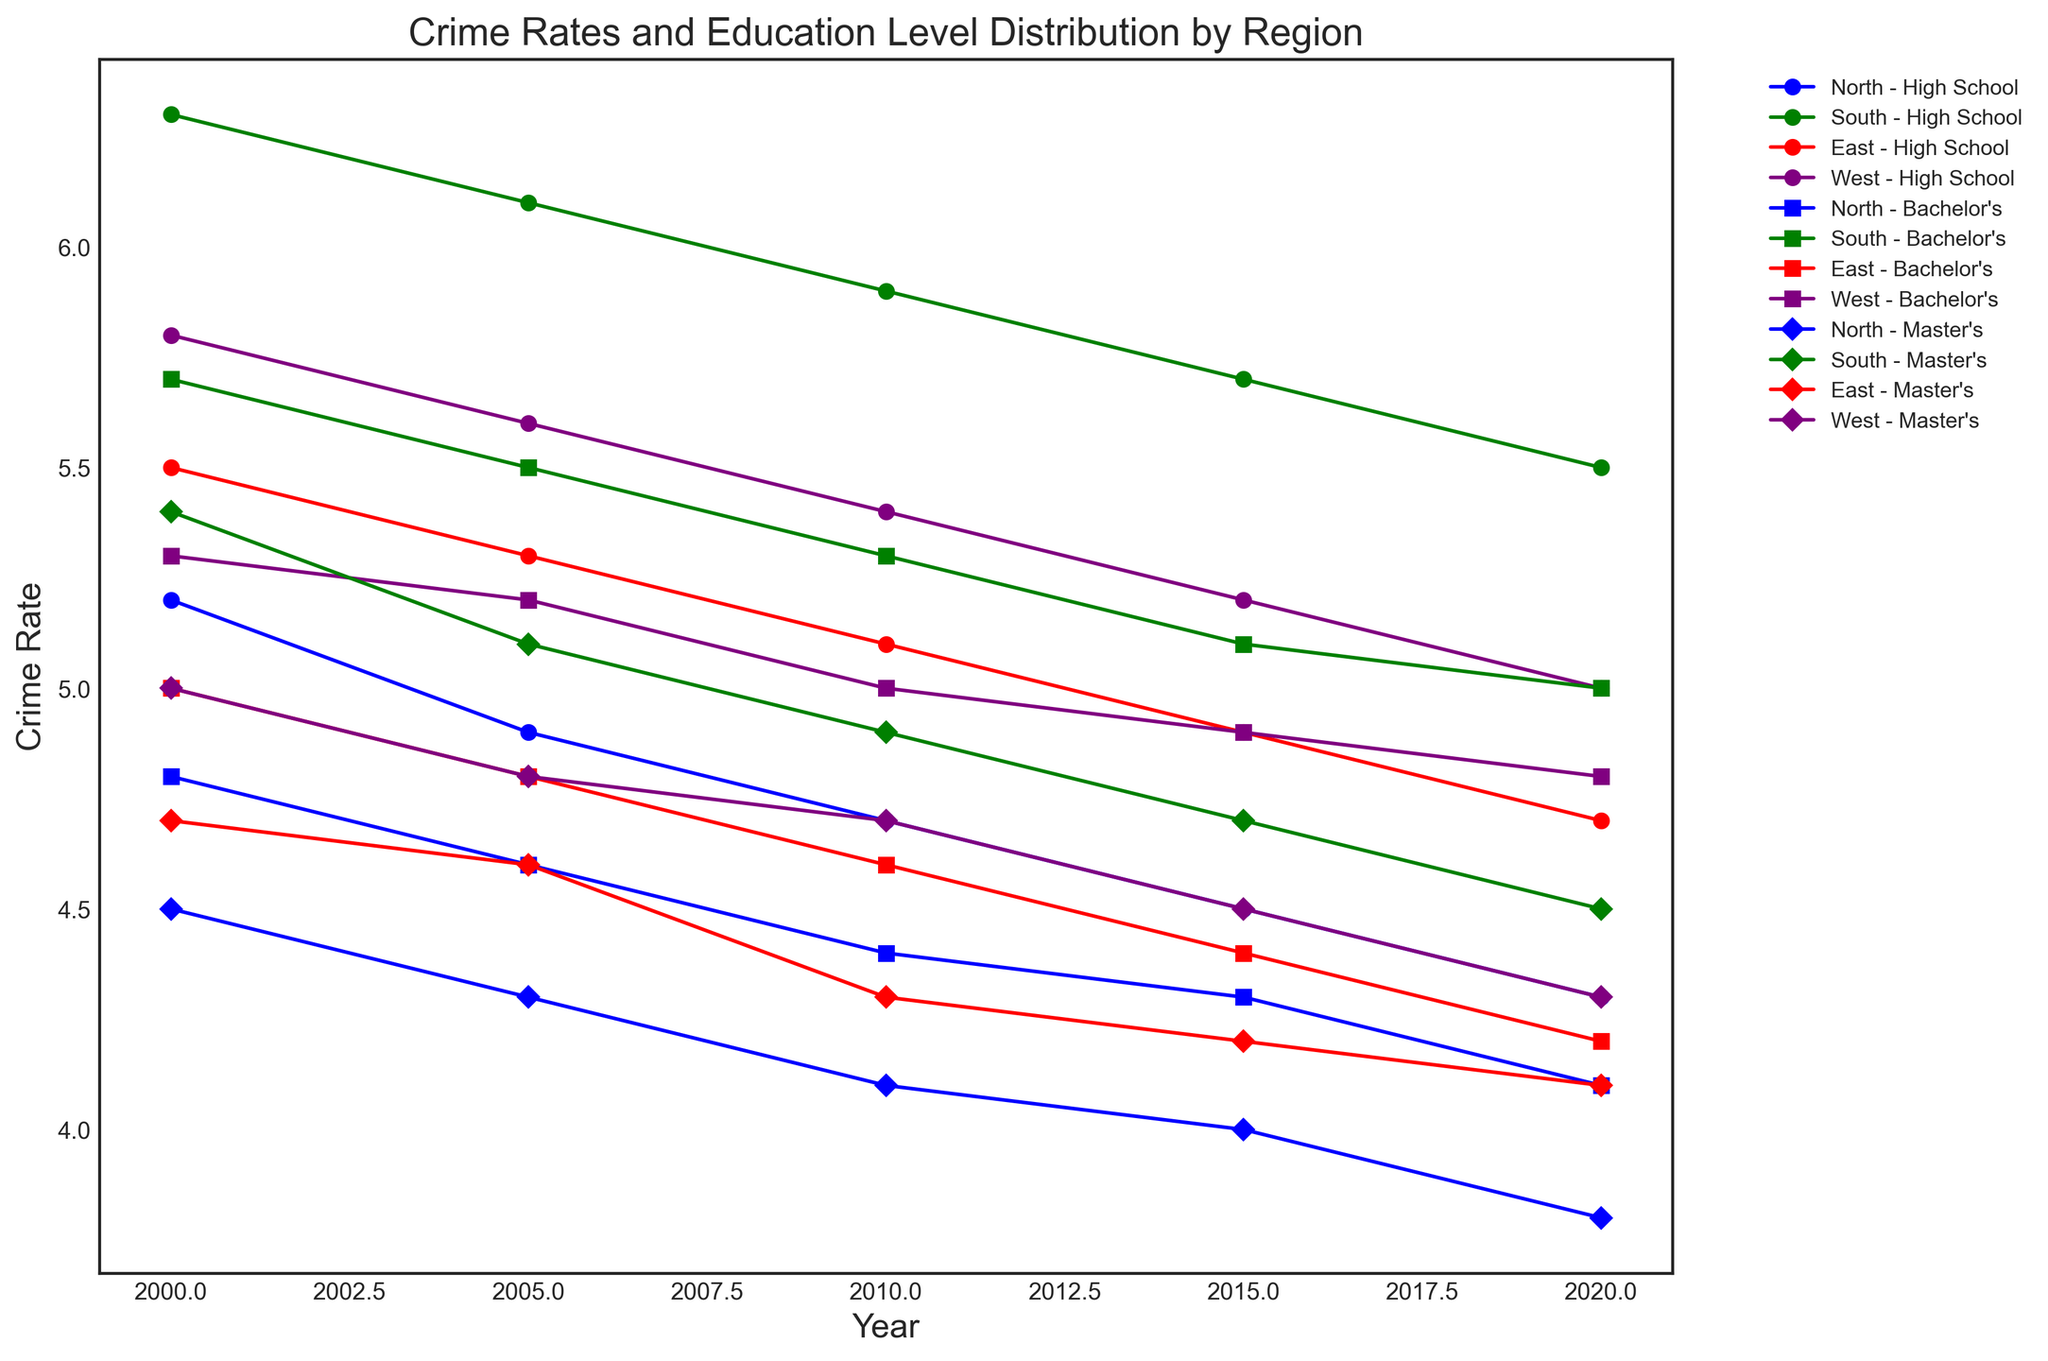Which region had the highest crime rate in 2020? To find the region with the highest crime rate in 2020, look for the point farthest up on the y-axis for the year 2020. From the data visualization, the South region had the highest crime rate in 2020.
Answer: South How did the crime rate change in the North region from 2000 to 2020? Observe the trend line for the North region across the years from 2000 to 2020. The crime rate in the North gradually decreased from 5.2 in 2000 to 4.3 in 2020.
Answer: Decreased Which region had the most significant decrease in crime rate for people with a high school level of education between 2000 and 2020? Compare the trend lines for each region's high school education level from 2000 to 2020. The North region showed the most significant decrease, going from 5.2 in 2000 to 4.3 in 2020.
Answer: North What is the difference in crime rates between the East and West regions for those with a Master's degree in 2020? Locate the 2020 data points for the East and West regions for people with a Master's degree. The crime rate is 4.1 in the East and 4.3 in the West. The difference is 4.3 - 4.1 = 0.2.
Answer: 0.2 Did the crime rate for any region with a Bachelor's degree increase from 2000 to 2020? Analyze the trend lines for each region with a Bachelor's degree. None of the regions showed an increase in the crime rate from 2000 to 2020; they either remained stable or decreased.
Answer: No In which region did people with a high school level of education experience the least change in crime rate from 2000 to 2020? Compare the crime rate from 2000 to 2020 for high school level education across different regions. The South region experienced the least change, going from 6.3 in 2000 to 5.5 in 2020.
Answer: South Which education level in the East region showed a consistent decrease in crime rate from 2000 to 2020? Observe the trend lines for each education level in the East region. The Master's degree showed a consistent decrease in crime rate, moving from 4.7 in 2000 to 4.1 in 2020.
Answer: Master's Is the trend for crime rates among those with a Bachelor's degree in the West region increasing, decreasing, or stable from 2000 to 2020? Follow the trend line for the West region with a Bachelor's degree from 2000 to 2020. The crime rate shows a decreasing trend, going from 5.3 in 2000 to 4.8 in 2020.
Answer: Decreasing 